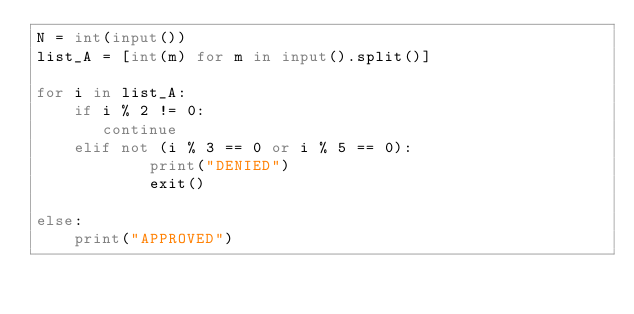Convert code to text. <code><loc_0><loc_0><loc_500><loc_500><_Python_>N = int(input())
list_A = [int(m) for m in input().split()]

for i in list_A:
    if i % 2 != 0:
       continue
    elif not (i % 3 == 0 or i % 5 == 0):
            print("DENIED")
            exit()

else:
    print("APPROVED")</code> 